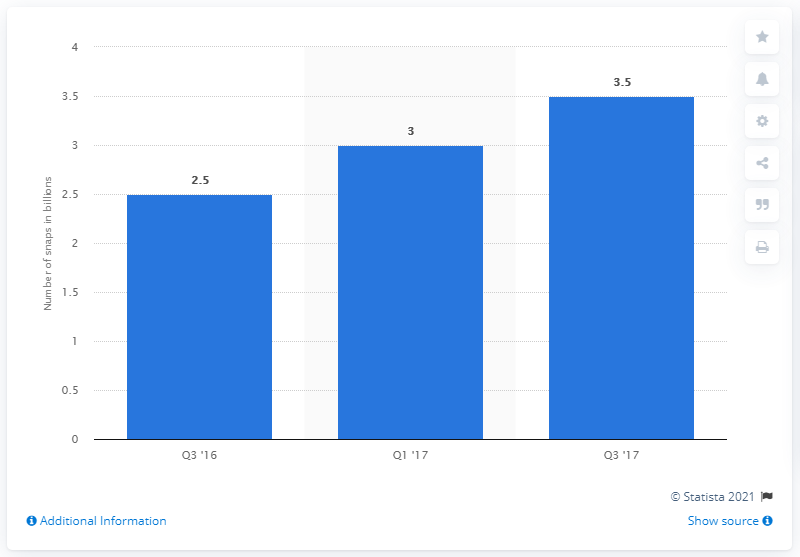Mention a couple of crucial points in this snapshot. Snapchat sent approximately 2.5 billion daily snaps in the third quarter of 2016. 